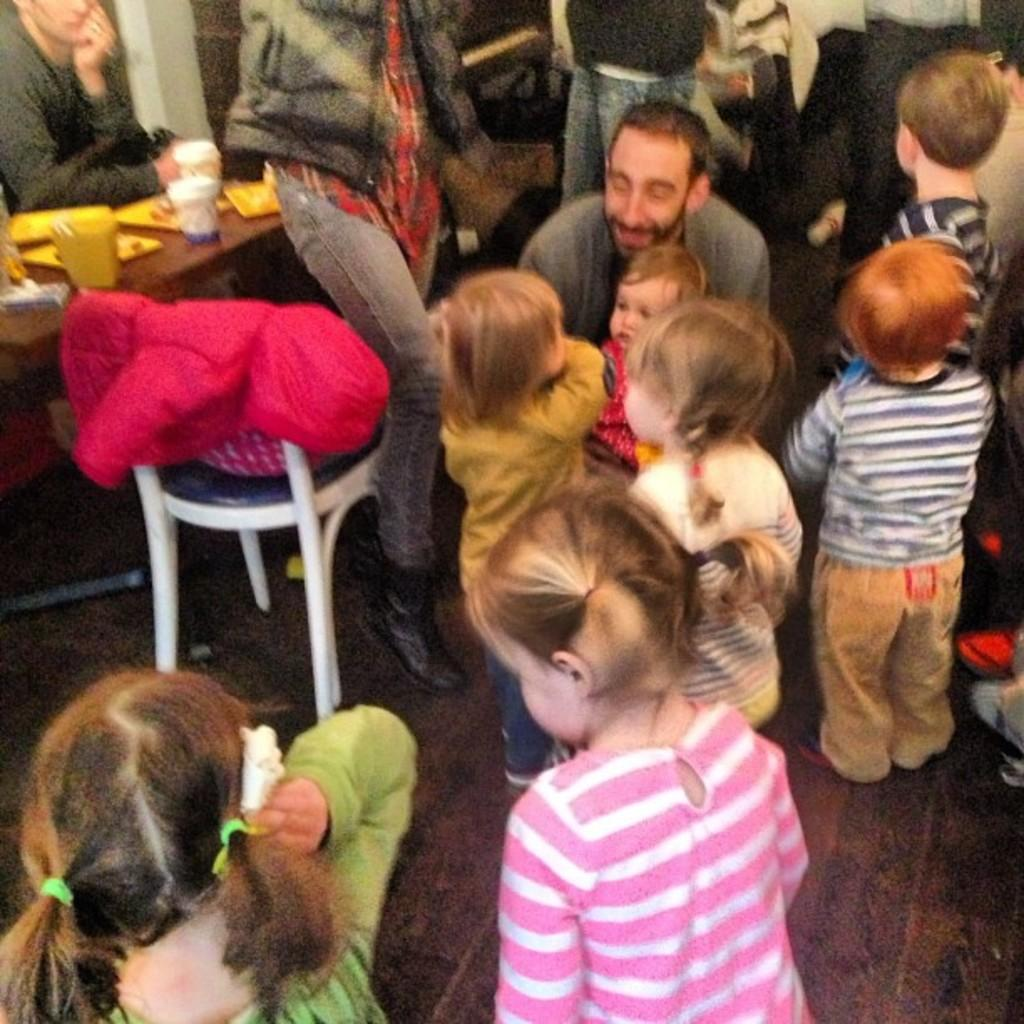How many people are in the image? There is a group of people in the image, but the exact number is not specified. What are the people doing in the image? The people are on the floor in the image. What furniture is present in the image? There is a table and a chair in the image. What can be found on the table? There are cups on the table in the image. What else can be seen in the image besides the people, table, chair, and cups? There are some unspecified objects in the image. How does the ship navigate through the temper in the image? There is no ship present in the image; it only features a group of people, furniture, cups, and unspecified objects. 